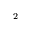Convert formula to latex. <formula><loc_0><loc_0><loc_500><loc_500>^ { 2 }</formula> 